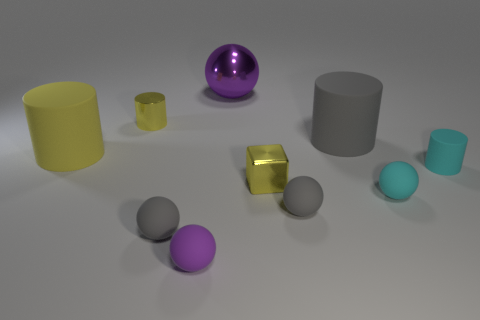Does the small metallic cylinder have the same color as the block?
Your answer should be compact. Yes. What number of other things are there of the same material as the large sphere
Provide a short and direct response. 2. There is a gray object that is in front of the yellow matte cylinder and right of the big purple object; what shape is it?
Your response must be concise. Sphere. There is a cyan rubber thing to the right of the tiny cyan sphere; does it have the same size as the rubber object that is on the left side of the small yellow shiny cylinder?
Make the answer very short. No. There is a small purple thing that is made of the same material as the tiny cyan cylinder; what shape is it?
Offer a very short reply. Sphere. What color is the ball that is behind the small thing that is left of the gray rubber object left of the large purple metal sphere?
Offer a very short reply. Purple. Is the number of big gray cylinders behind the big purple shiny ball less than the number of small gray matte objects in front of the cube?
Offer a very short reply. Yes. Is the shape of the big gray rubber thing the same as the big purple thing?
Keep it short and to the point. No. What number of purple matte objects are the same size as the cyan matte ball?
Provide a succinct answer. 1. Is the number of cyan matte spheres to the right of the tiny rubber cylinder less than the number of small purple spheres?
Keep it short and to the point. Yes. 